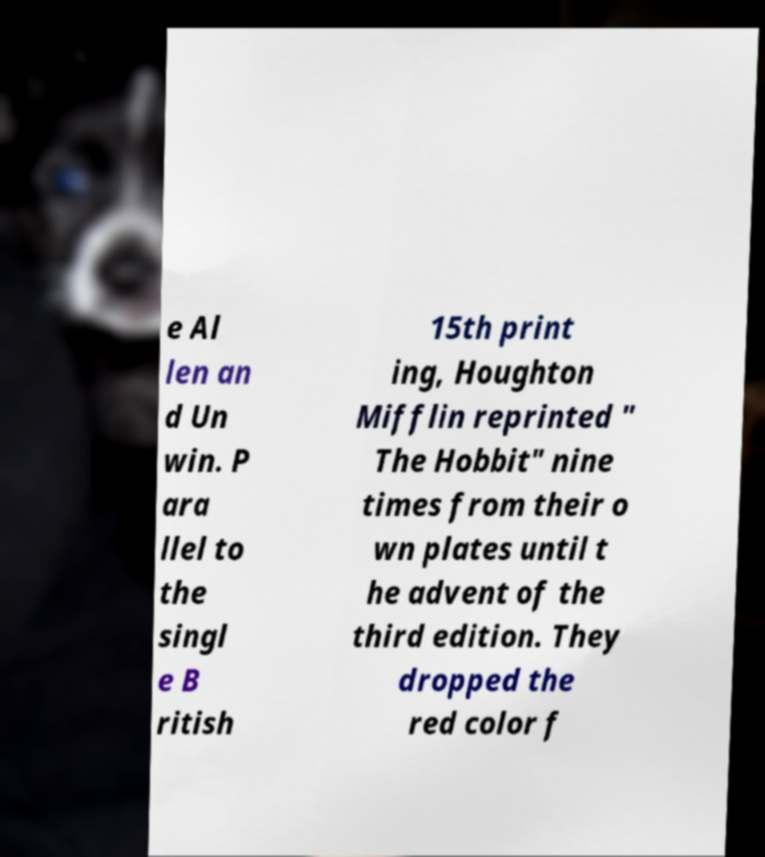For documentation purposes, I need the text within this image transcribed. Could you provide that? e Al len an d Un win. P ara llel to the singl e B ritish 15th print ing, Houghton Mifflin reprinted " The Hobbit" nine times from their o wn plates until t he advent of the third edition. They dropped the red color f 